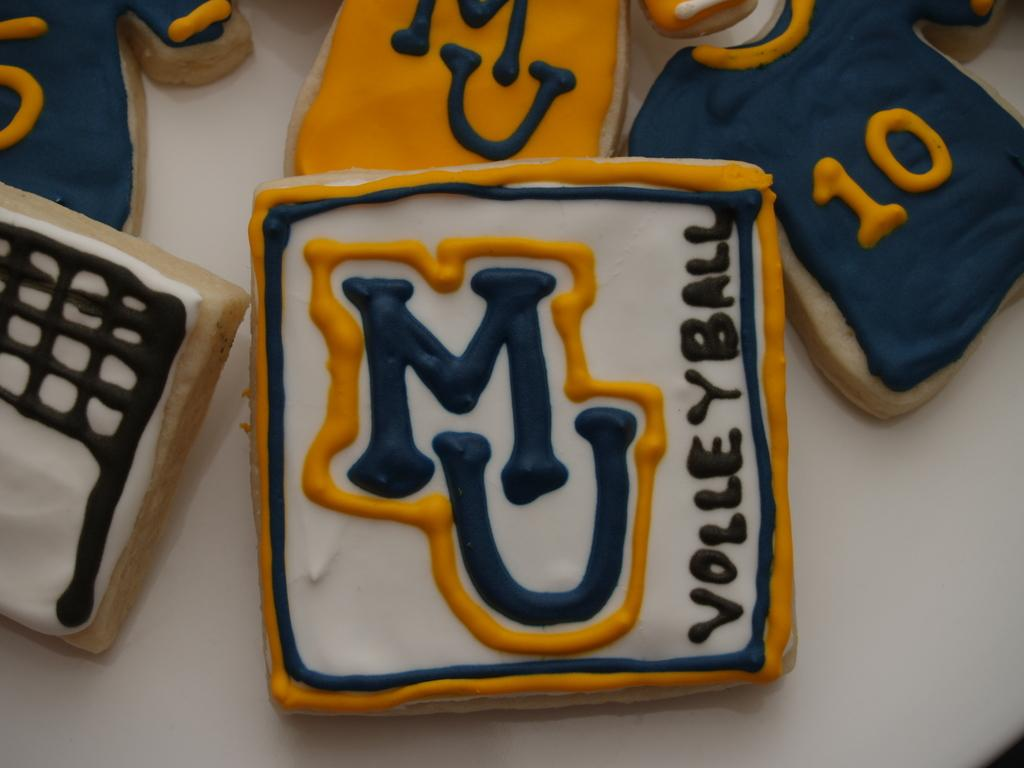<image>
Present a compact description of the photo's key features. An assortment of cookies are decorated to look like team shirts, a net, and the image of the MU Volleyball logo. 